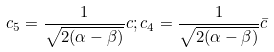Convert formula to latex. <formula><loc_0><loc_0><loc_500><loc_500>c _ { 5 } = \frac { 1 } { \sqrt { 2 ( \alpha - \beta ) } } c ; c _ { 4 } = \frac { 1 } { \sqrt { 2 ( \alpha - \beta ) } } \bar { c }</formula> 